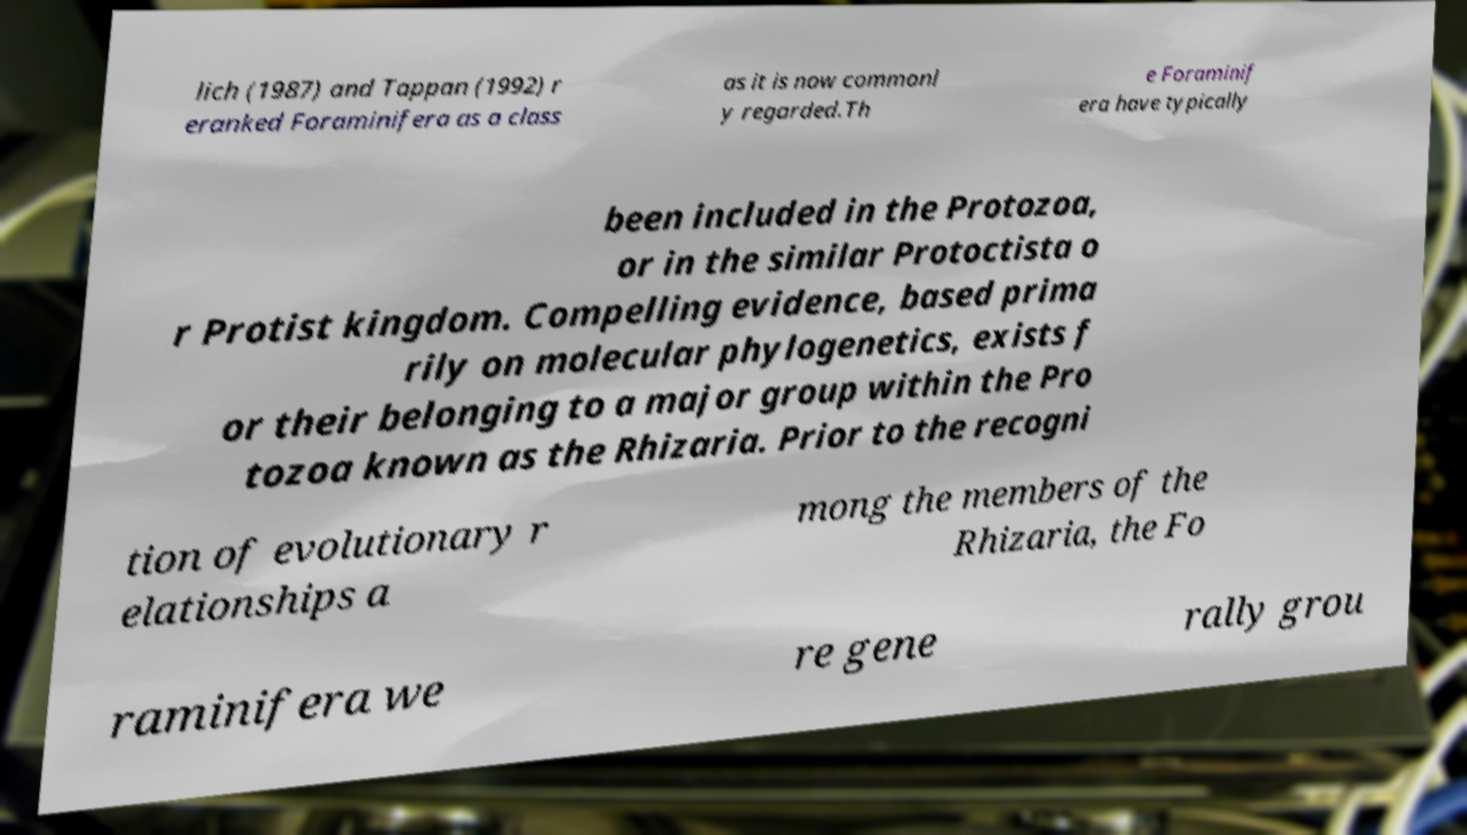What messages or text are displayed in this image? I need them in a readable, typed format. lich (1987) and Tappan (1992) r eranked Foraminifera as a class as it is now commonl y regarded.Th e Foraminif era have typically been included in the Protozoa, or in the similar Protoctista o r Protist kingdom. Compelling evidence, based prima rily on molecular phylogenetics, exists f or their belonging to a major group within the Pro tozoa known as the Rhizaria. Prior to the recogni tion of evolutionary r elationships a mong the members of the Rhizaria, the Fo raminifera we re gene rally grou 